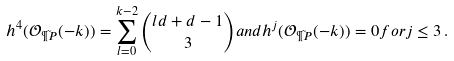Convert formula to latex. <formula><loc_0><loc_0><loc_500><loc_500>h ^ { 4 } ( { \mathcal { O } } _ { \tilde { \P P } } ( - k ) ) = \sum _ { l = 0 } ^ { k - 2 } \binom { l d + d - 1 } 3 a n d h ^ { j } ( { \mathcal { O } } _ { \tilde { \P P } } ( - k ) ) = 0 f o r j \leq 3 \, .</formula> 